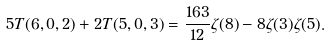<formula> <loc_0><loc_0><loc_500><loc_500>5 T ( 6 , 0 , 2 ) + 2 T ( 5 , 0 , 3 ) = \frac { 1 6 3 } { 1 2 } \zeta ( 8 ) - 8 \zeta ( 3 ) \zeta ( 5 ) .</formula> 